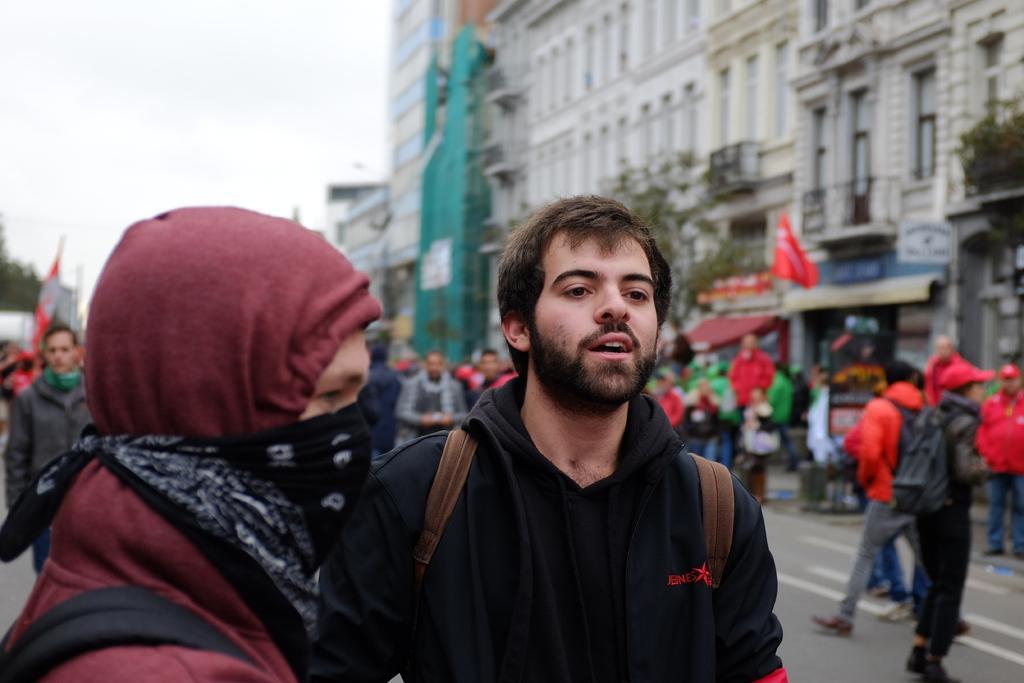How would you summarize this image in a sentence or two? This image consists of some persons in the middle. There is building in the middle. There is sky at the top 